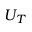<formula> <loc_0><loc_0><loc_500><loc_500>U _ { T }</formula> 